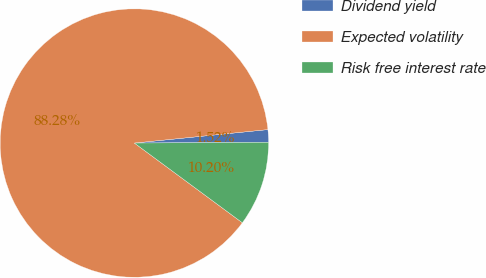Convert chart to OTSL. <chart><loc_0><loc_0><loc_500><loc_500><pie_chart><fcel>Dividend yield<fcel>Expected volatility<fcel>Risk free interest rate<nl><fcel>1.52%<fcel>88.27%<fcel>10.2%<nl></chart> 